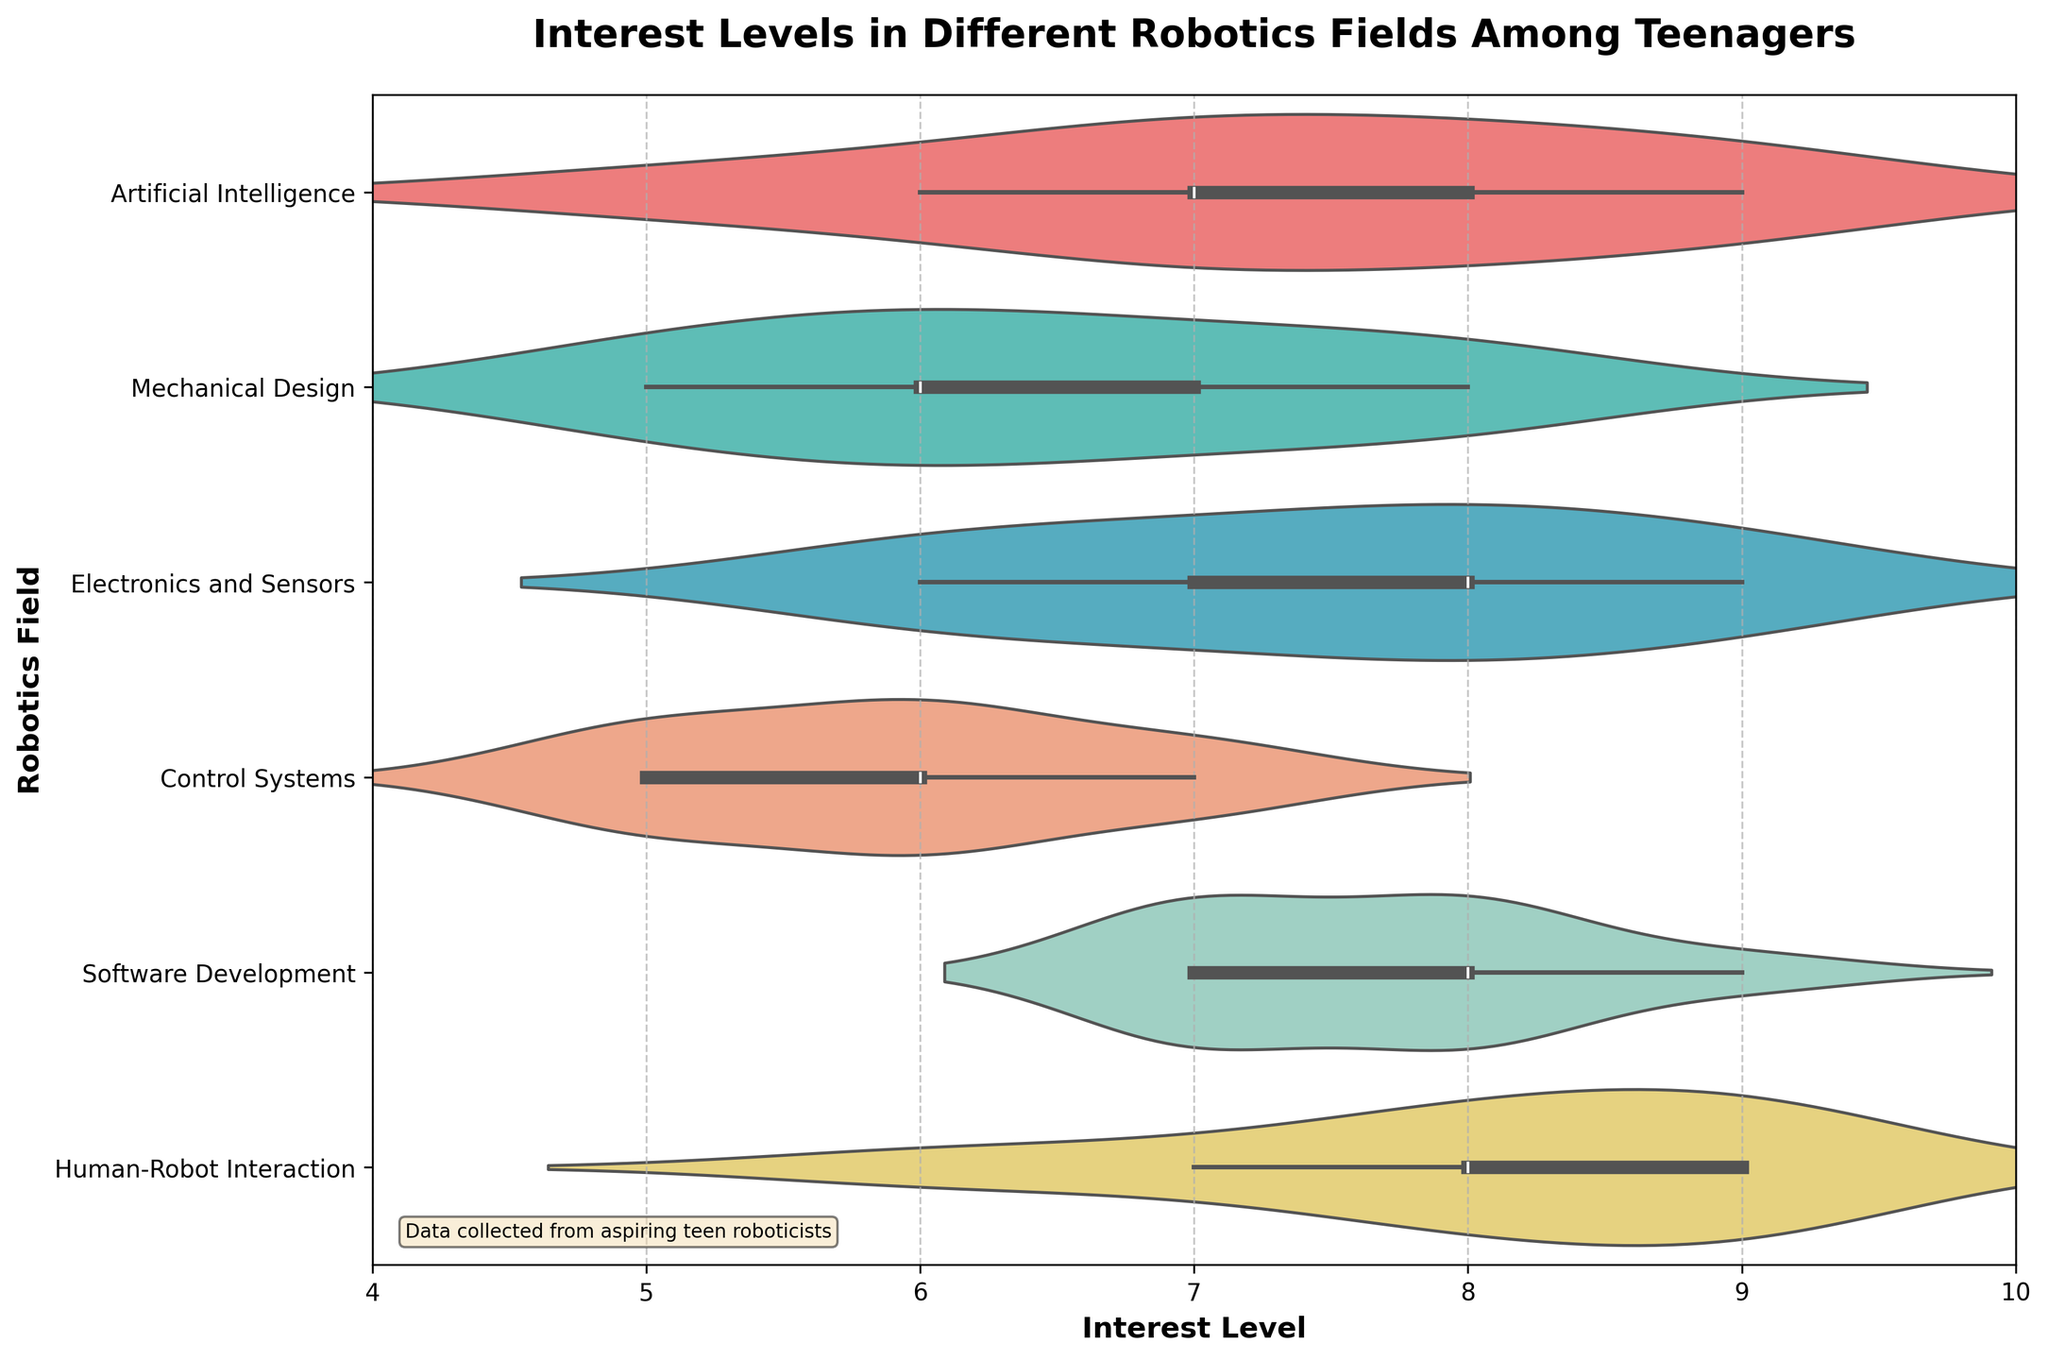What is the title of the chart? The title of the chart is usually displayed at the top of the chart. In this case, it reads "Interest Levels in Different Robotics Fields Among Teenagers".
Answer: Interest Levels in Different Robotics Fields Among Teenagers What is the field with the highest median interest level? By examining the horizontal lines within each violin plot, which represent the median values, we can see that "Human-Robot Interaction" has the highest median interest level, around 8.5.
Answer: Human-Robot Interaction How many fields have a maximum interest level value of 9? Observing the right end of each violin plot, we see that "Artificial Intelligence", "Electronics and Sensors", "Software Development", and "Human-Robot Interaction" all have data points reaching a value of 9.
Answer: Four fields What is the range of interest levels in "Control Systems"? The range of a field's interest level can be determined by examining the spread of the violin plot; for "Control Systems", it spans from 5 to 7.
Answer: 5 to 7 Which fields have their minimum interest level data point at 6? Looking at the left end of the violin plots, "Artificial Intelligence", "Electronics and Sensors", and "Human-Robot Interaction" show their lower bounds starting at 6.
Answer: Artificial Intelligence, Electronics and Sensors, Human-Robot Interaction Compare the distribution of interest levels for "Mechanical Design" and "Control Systems". Which has a wider spread? By comparing the width of the violin plots horizontally, we see that "Mechanical Design" has a wider spread than "Control Systems", ranging from 5 to 8 versus 5 to 7.
Answer: Mechanical Design What is the average interest level for "Software Development"? Adding all interest level points for "Software Development" (7, 8, 8, 7, 9, 7, 8, 7, 8) gives 69. Dividing by the number of points (9) gives an average of 69/9.
Answer: 7.67 Is the distribution of interest levels in "Artificial Intelligence" symmetric or asymmetric? Looking at the shape of the violin plot for "Artificial Intelligence", it appears to be symmetric since it visually mirrors around its central axis.
Answer: Symmetric Which field shows the least variation in interest levels? The plot with the smallest spread indicates the least variation. "Control Systems" has the spread from 5 to 7, which is the narrowest among the fields.
Answer: Control Systems 